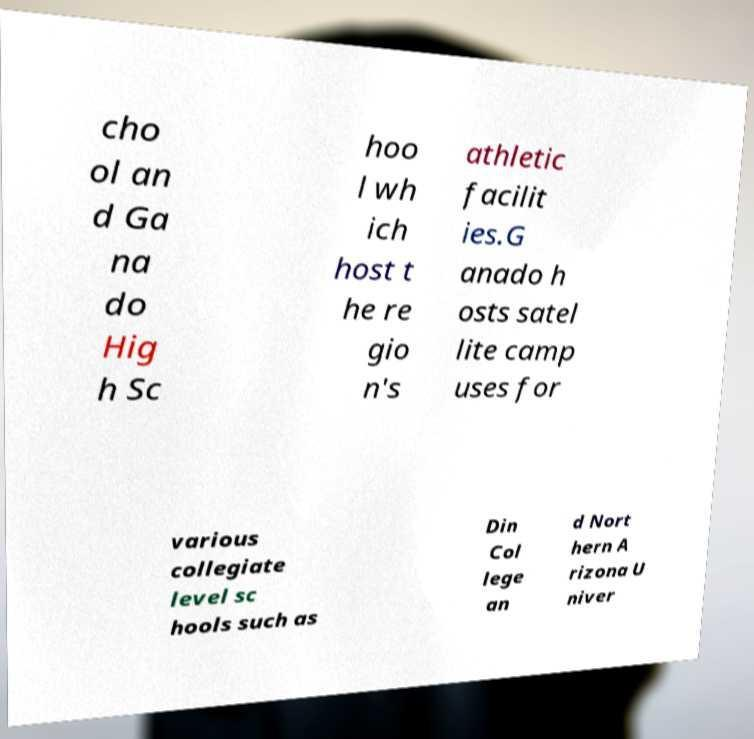For documentation purposes, I need the text within this image transcribed. Could you provide that? cho ol an d Ga na do Hig h Sc hoo l wh ich host t he re gio n's athletic facilit ies.G anado h osts satel lite camp uses for various collegiate level sc hools such as Din Col lege an d Nort hern A rizona U niver 